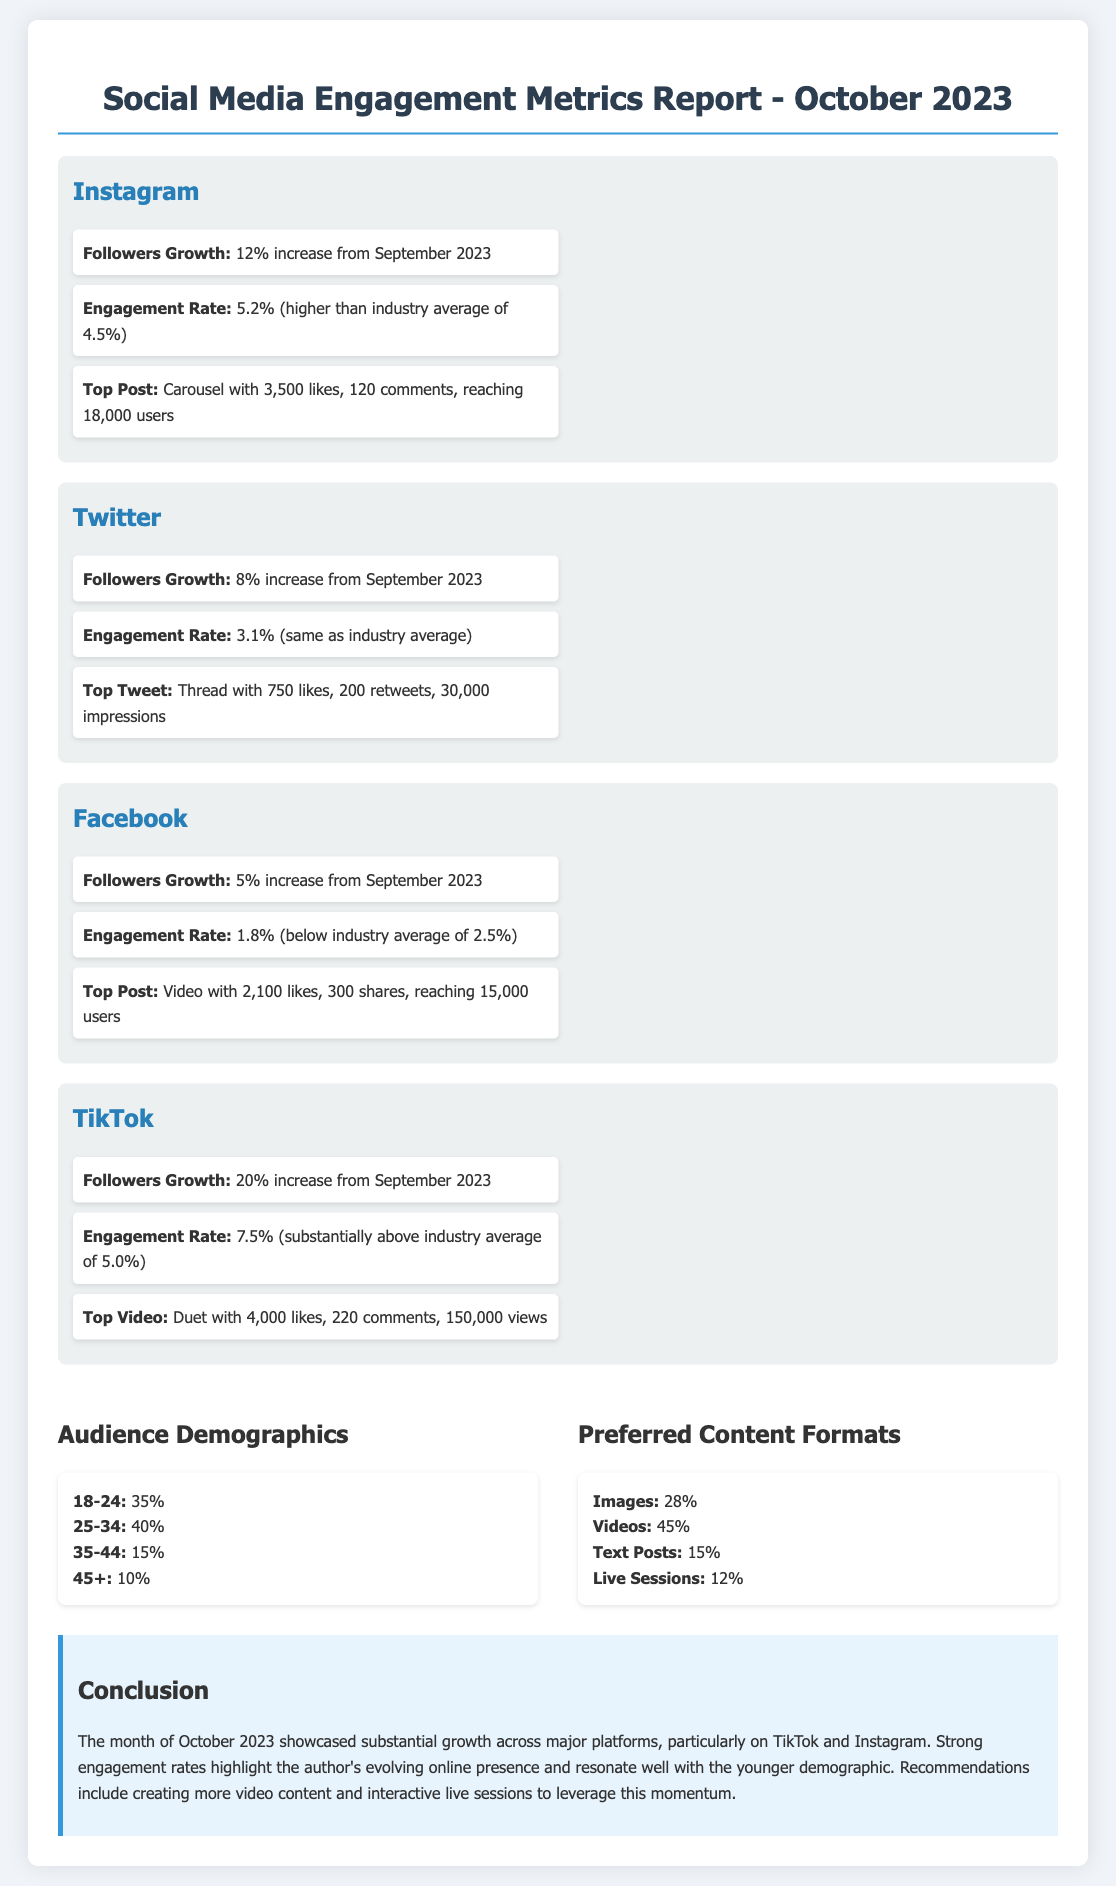What was the percentage increase in Instagram followers? The document states that there was a 12% increase in Instagram followers from September 2023.
Answer: 12% What was the engagement rate for TikTok? The document reports that the engagement rate for TikTok was 7.5%.
Answer: 7.5% Which platform had the highest followers growth? The growth data shows that TikTok had the highest followers growth at 20%.
Answer: 20% What was the industry average engagement rate for Twitter? The document mentions that Twitter's engagement rate was 3.1%, which is the same as the industry average.
Answer: 3.1% What demographic comprises the largest percentage of the audience? According to the audience demographics section, the largest age group is 25-34 at 40%.
Answer: 25-34 What type of content format is preferred most by the audience? The preferred content formats indicate that videos are the most preferred at 45%.
Answer: Videos What was the top post on Facebook? The top post on Facebook was a video with 2,100 likes and 300 shares.
Answer: Video with 2,100 likes What conclusion is drawn about the engagement rates? The conclusion highlights that strong engagement rates indicate the author's evolving online presence.
Answer: Strong engagement rates What recommendation is made for leveraging momentum? The document recommends creating more video content and interactive live sessions.
Answer: More video content and interactive live sessions 